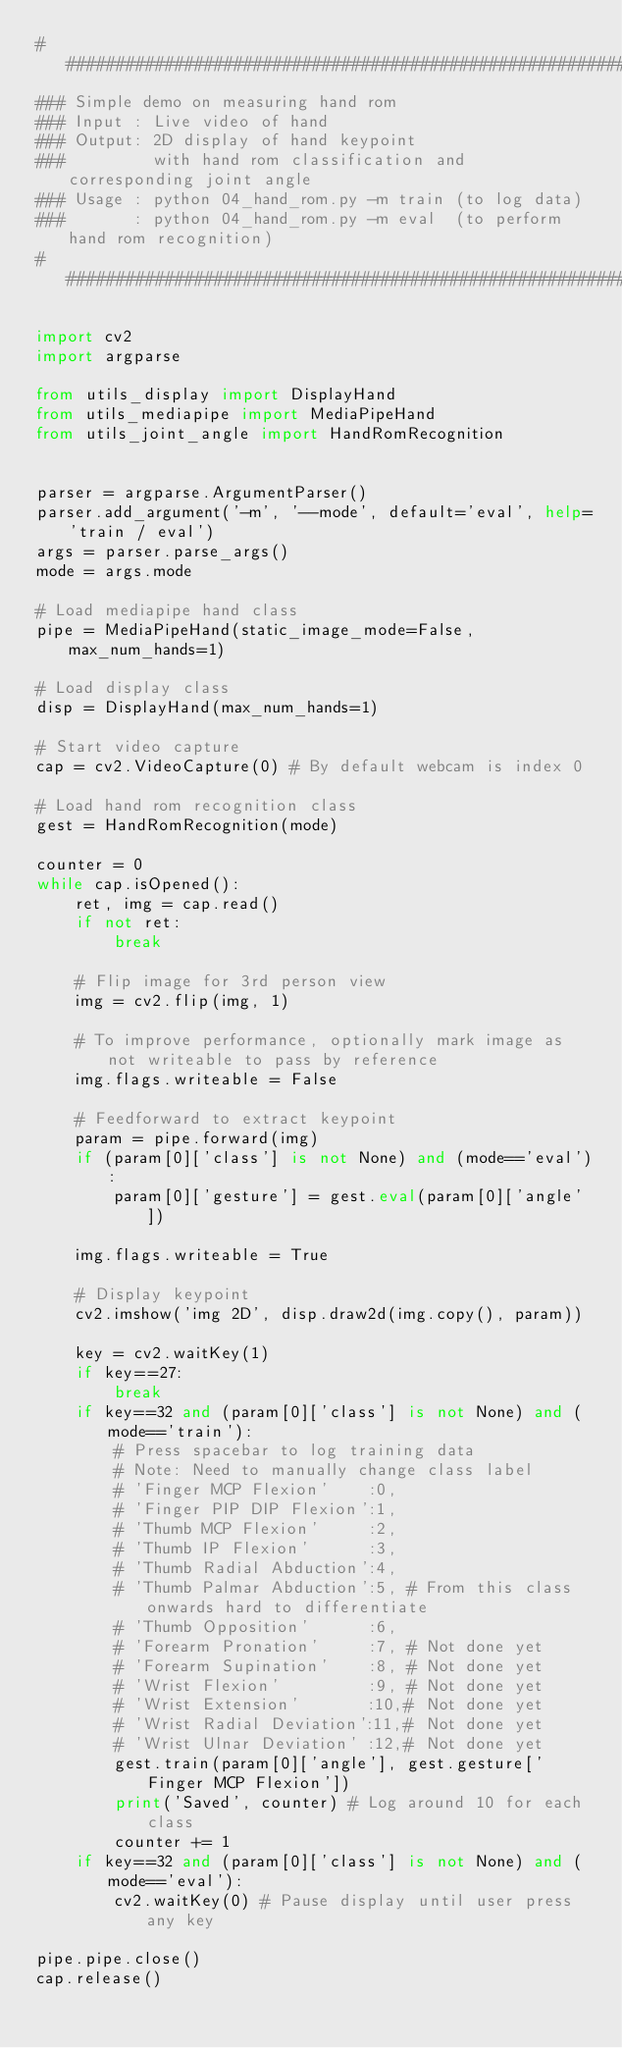Convert code to text. <code><loc_0><loc_0><loc_500><loc_500><_Python_>###############################################################################
### Simple demo on measuring hand rom
### Input : Live video of hand
### Output: 2D display of hand keypoint 
###         with hand rom classification and corresponding joint angle
### Usage : python 04_hand_rom.py -m train (to log data)
###       : python 04_hand_rom.py -m eval  (to perform hand rom recognition)
###############################################################################

import cv2
import argparse

from utils_display import DisplayHand
from utils_mediapipe import MediaPipeHand
from utils_joint_angle import HandRomRecognition


parser = argparse.ArgumentParser()
parser.add_argument('-m', '--mode', default='eval', help='train / eval')
args = parser.parse_args()
mode = args.mode

# Load mediapipe hand class
pipe = MediaPipeHand(static_image_mode=False, max_num_hands=1)

# Load display class
disp = DisplayHand(max_num_hands=1)

# Start video capture
cap = cv2.VideoCapture(0) # By default webcam is index 0

# Load hand rom recognition class
gest = HandRomRecognition(mode)

counter = 0
while cap.isOpened():
    ret, img = cap.read()
    if not ret:
        break

    # Flip image for 3rd person view
    img = cv2.flip(img, 1)

    # To improve performance, optionally mark image as not writeable to pass by reference
    img.flags.writeable = False

    # Feedforward to extract keypoint
    param = pipe.forward(img)
    if (param[0]['class'] is not None) and (mode=='eval'):
        param[0]['gesture'] = gest.eval(param[0]['angle'])

    img.flags.writeable = True

    # Display keypoint
    cv2.imshow('img 2D', disp.draw2d(img.copy(), param))

    key = cv2.waitKey(1)
    if key==27:
        break
    if key==32 and (param[0]['class'] is not None) and (mode=='train'):
        # Press spacebar to log training data
        # Note: Need to manually change class label
        # 'Finger MCP Flexion'    :0,
        # 'Finger PIP DIP Flexion':1,
        # 'Thumb MCP Flexion'     :2,
        # 'Thumb IP Flexion'      :3,
        # 'Thumb Radial Abduction':4,
        # 'Thumb Palmar Abduction':5, # From this class onwards hard to differentiate
        # 'Thumb Opposition'      :6,
        # 'Forearm Pronation'     :7, # Not done yet
        # 'Forearm Supination'    :8, # Not done yet
        # 'Wrist Flexion'         :9, # Not done yet
        # 'Wrist Extension'       :10,# Not done yet
        # 'Wrist Radial Deviation':11,# Not done yet
        # 'Wrist Ulnar Deviation' :12,# Not done yet
        gest.train(param[0]['angle'], gest.gesture['Finger MCP Flexion'])
        print('Saved', counter) # Log around 10 for each class
        counter += 1
    if key==32 and (param[0]['class'] is not None) and (mode=='eval'):
        cv2.waitKey(0) # Pause display until user press any key

pipe.pipe.close()
cap.release()
</code> 